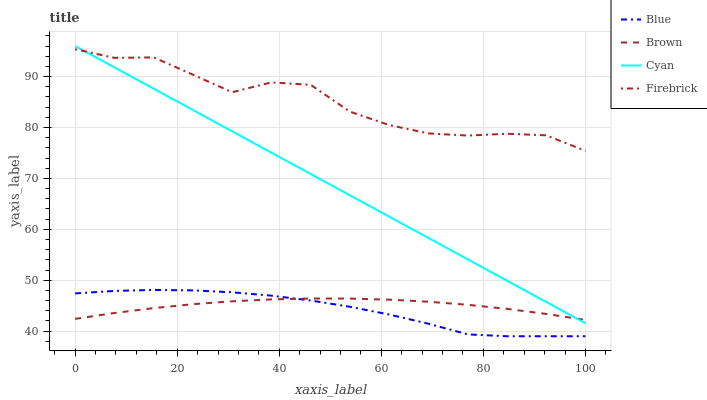Does Blue have the minimum area under the curve?
Answer yes or no. Yes. Does Firebrick have the maximum area under the curve?
Answer yes or no. Yes. Does Brown have the minimum area under the curve?
Answer yes or no. No. Does Brown have the maximum area under the curve?
Answer yes or no. No. Is Cyan the smoothest?
Answer yes or no. Yes. Is Firebrick the roughest?
Answer yes or no. Yes. Is Brown the smoothest?
Answer yes or no. No. Is Brown the roughest?
Answer yes or no. No. Does Brown have the lowest value?
Answer yes or no. No. Does Cyan have the highest value?
Answer yes or no. Yes. Does Firebrick have the highest value?
Answer yes or no. No. Is Blue less than Firebrick?
Answer yes or no. Yes. Is Cyan greater than Blue?
Answer yes or no. Yes. Does Blue intersect Brown?
Answer yes or no. Yes. Is Blue less than Brown?
Answer yes or no. No. Is Blue greater than Brown?
Answer yes or no. No. Does Blue intersect Firebrick?
Answer yes or no. No. 